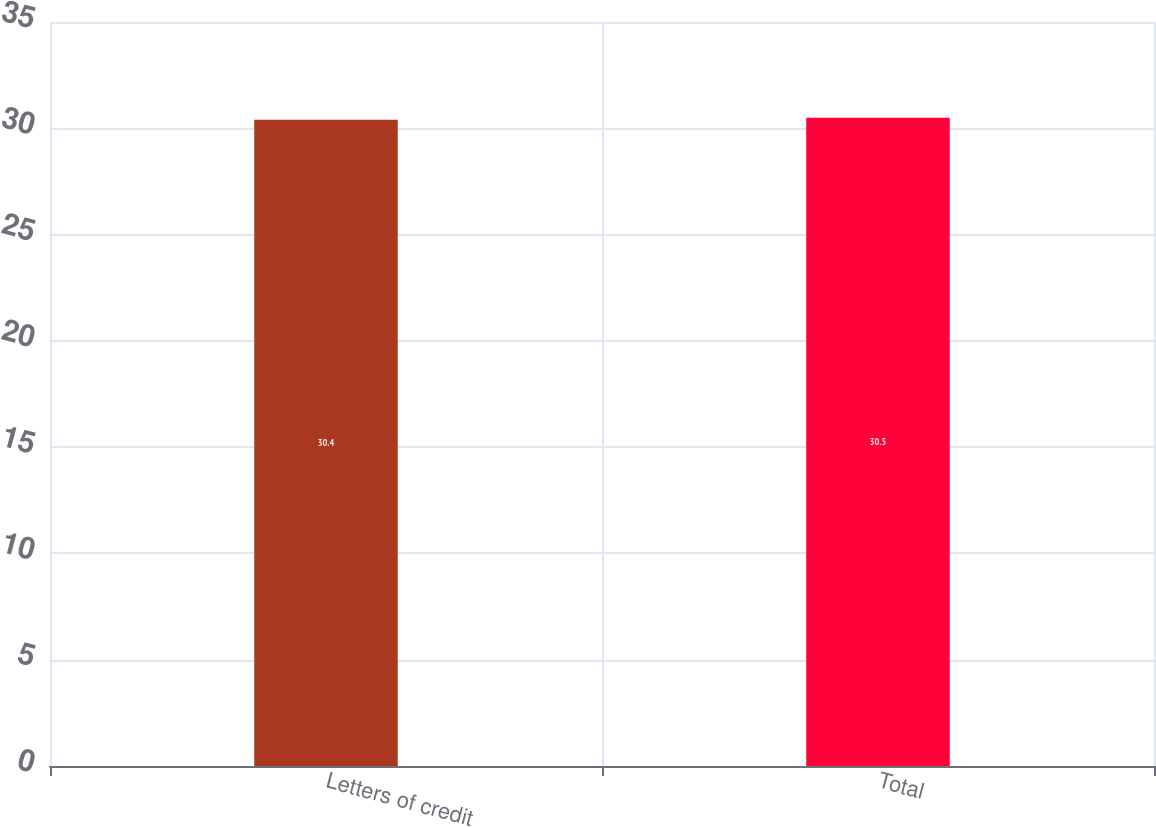<chart> <loc_0><loc_0><loc_500><loc_500><bar_chart><fcel>Letters of credit<fcel>Total<nl><fcel>30.4<fcel>30.5<nl></chart> 